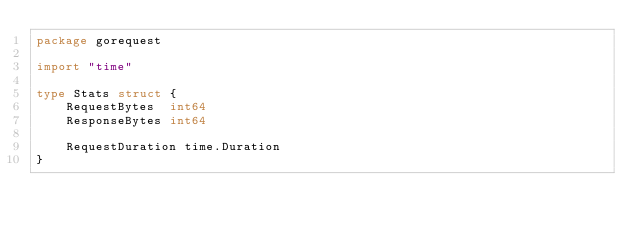<code> <loc_0><loc_0><loc_500><loc_500><_Go_>package gorequest

import "time"

type Stats struct {
	RequestBytes  int64
	ResponseBytes int64

	RequestDuration time.Duration
}
</code> 